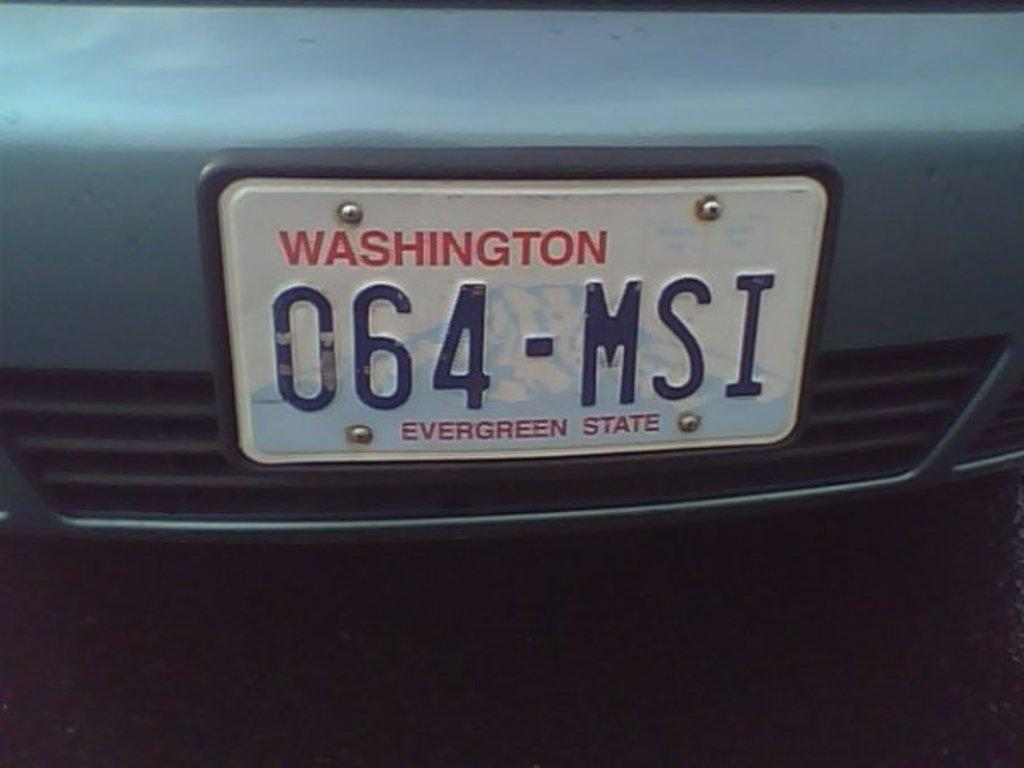What is the main subject of the picture? The main subject of the picture is a vehicle. What feature of the vehicle is mentioned in the facts? The vehicle has a registration plate. What can be found on the registration plate? There are screws and writing on the registration plate. How many family members are visible in the picture? There are no family members visible in the picture; it only features a vehicle with a registration plate. What type of rock is being used to patch the vehicle in the image? There is no rock or patching visible in the image; it only shows a vehicle with a registration plate. 